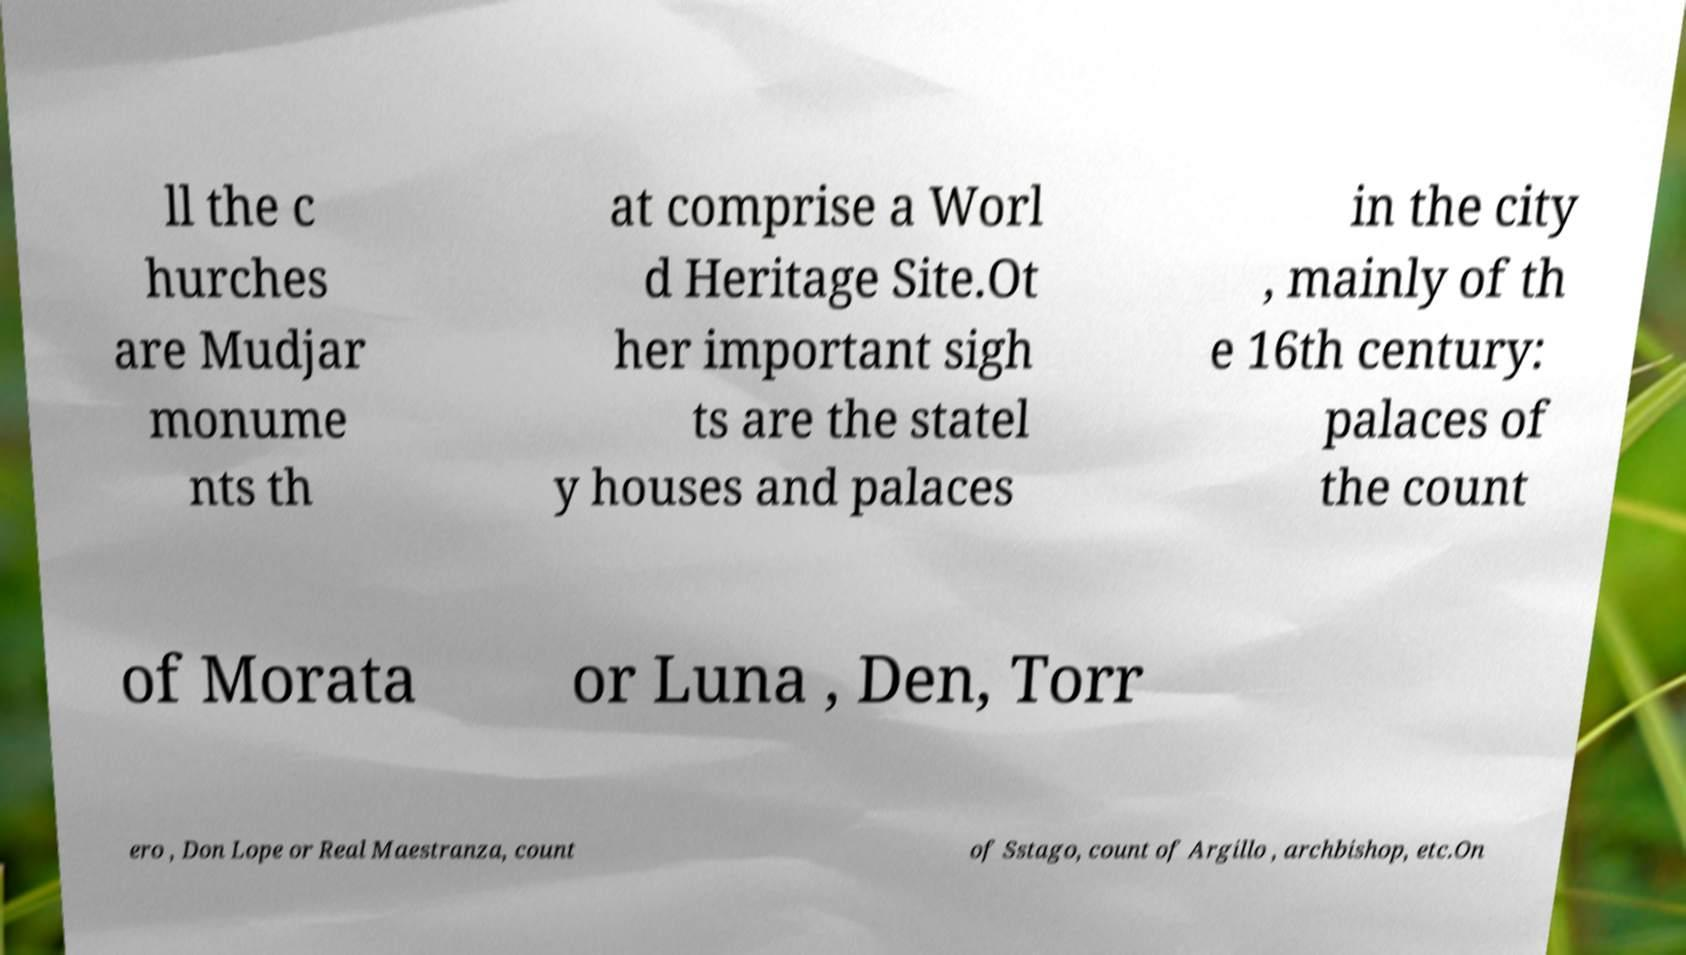Please identify and transcribe the text found in this image. ll the c hurches are Mudjar monume nts th at comprise a Worl d Heritage Site.Ot her important sigh ts are the statel y houses and palaces in the city , mainly of th e 16th century: palaces of the count of Morata or Luna , Den, Torr ero , Don Lope or Real Maestranza, count of Sstago, count of Argillo , archbishop, etc.On 